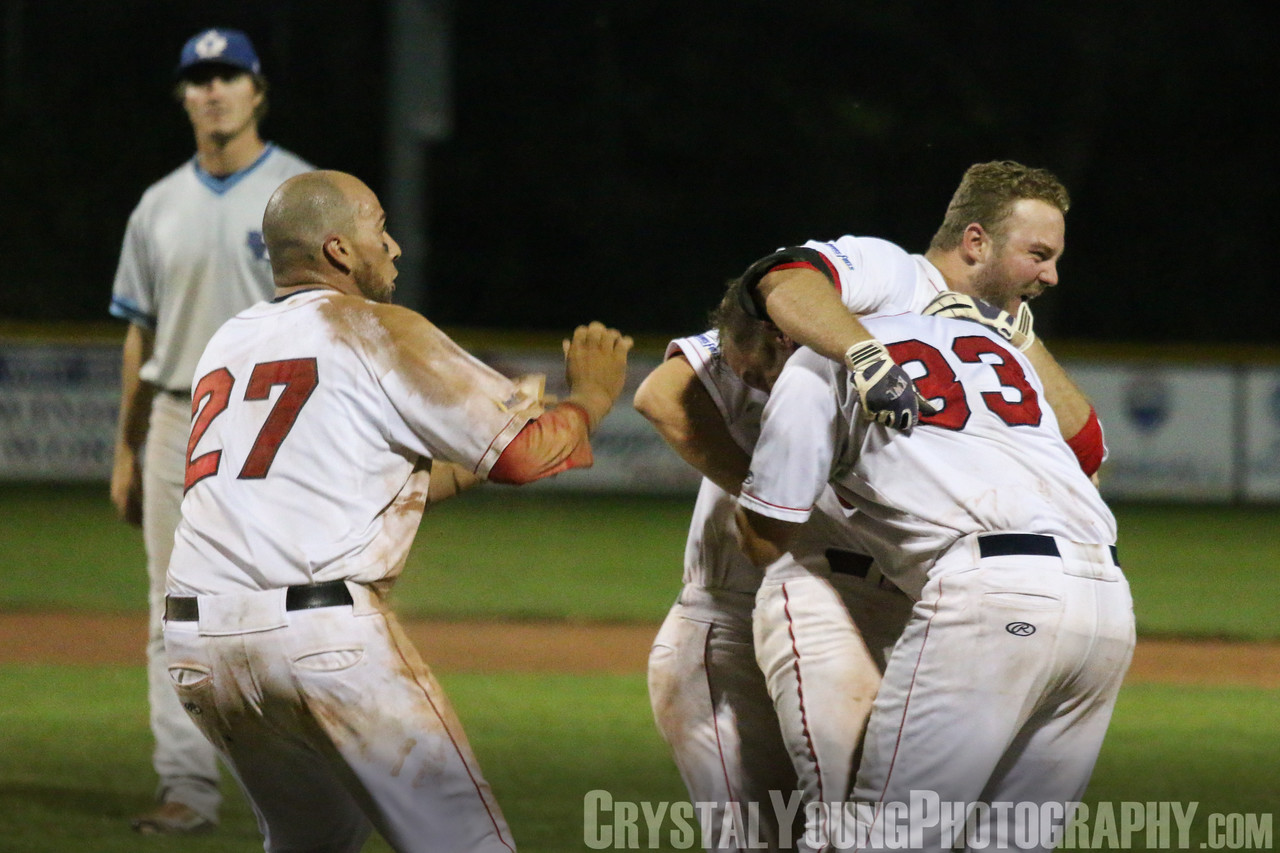What strategies might the team have employed during the game to achieve their victory? To achieve their victory, the team may have employed a variety of effective strategies. This could include a strong offensive approach, such as timely hitting and aggressive base running, as well as a solid defensive setup that minimized the opposing team's scoring opportunities. Pitching might have been a key factor, with the pitchers executing their pitching plans flawlessly to keep the opponents at bay. The players' strong chemistry and teamwork are evident in their celebration, suggesting that effective communication and cohesive play were also crucial elements in their success. 